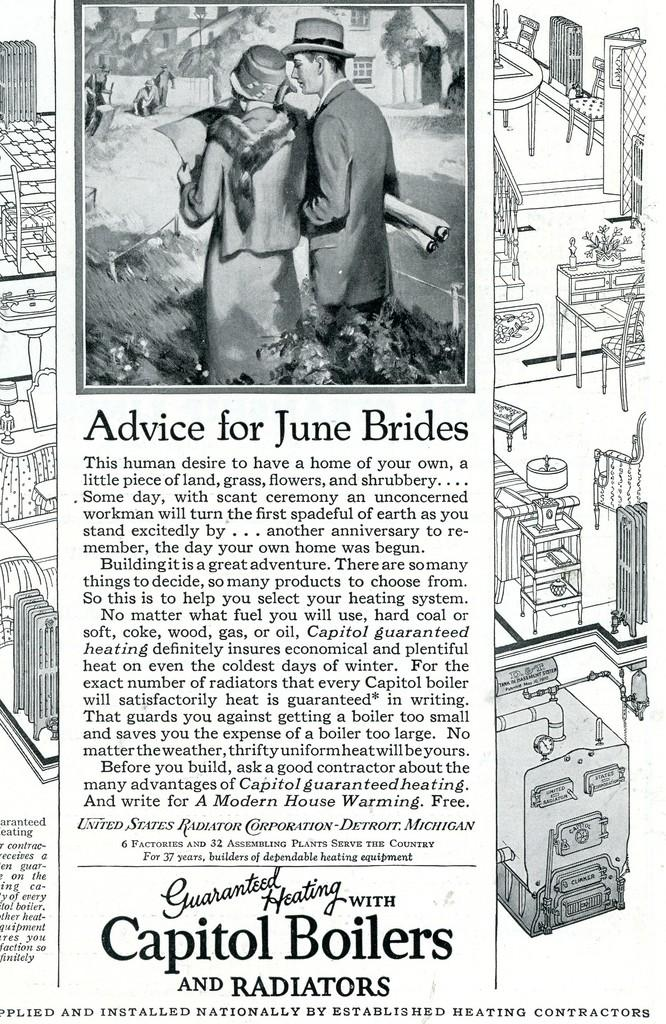What is the main subject of the image? There is an article in the image. What can be found on the article? There is writing and images on the article. Who is visible in the image? People are visible in the image. What type of structure is present in the image? There is a house in the image. What type of furniture is present in the image? Tables are present in the image. What else can be found in the image? There are objects in the image. What type of ant is visible in the image? There are no ants present in the image. What is the position of the partner in the image? There is no mention of a partner in the image. 